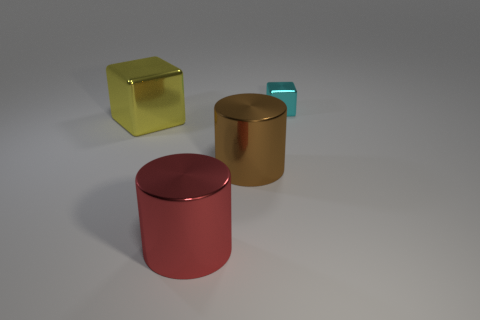Is there any other thing that is the same color as the large shiny block?
Provide a succinct answer. No. There is a yellow shiny cube that is left of the big metallic cylinder that is behind the red object; is there a thing behind it?
Offer a very short reply. Yes. The large metal block is what color?
Offer a very short reply. Yellow. Are there any brown things in front of the yellow object?
Provide a short and direct response. Yes. There is a big yellow object; does it have the same shape as the thing behind the yellow thing?
Provide a short and direct response. Yes. How many other things are there of the same material as the big red thing?
Offer a terse response. 3. There is a object that is behind the metal cube to the left of the thing behind the yellow object; what is its color?
Your answer should be compact. Cyan. What is the shape of the thing behind the metal block that is on the left side of the large red object?
Keep it short and to the point. Cube. Is the number of brown metallic cylinders that are behind the cyan block greater than the number of small blue metal cylinders?
Your response must be concise. No. Does the big shiny thing that is right of the large red thing have the same shape as the big yellow object?
Give a very brief answer. No. 